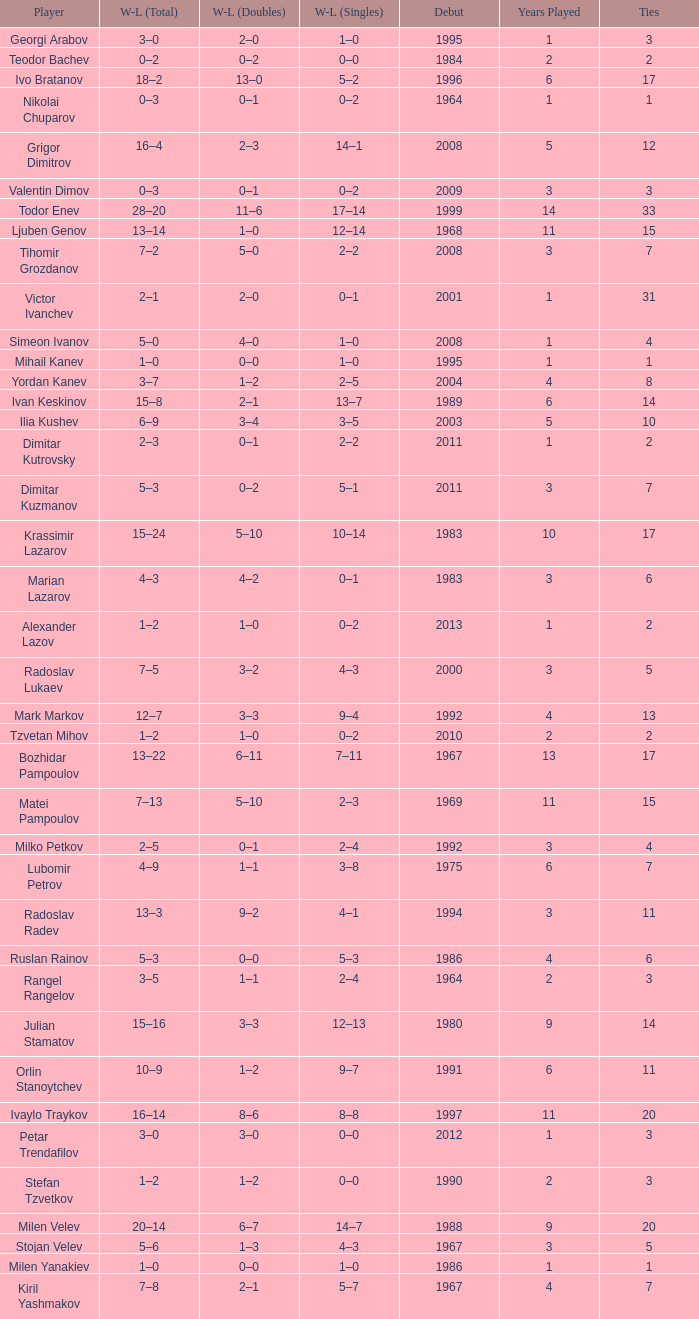Tell me the WL doubles with a debut of 1999 11–6. 